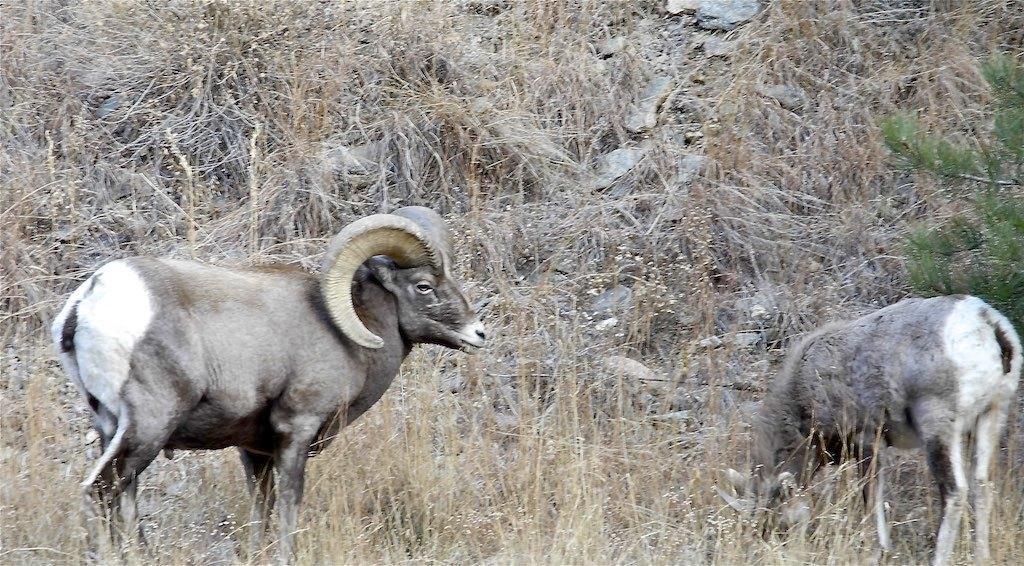Can you describe this image briefly? There are two animals standing in the grass. On the right side we can see branch of a tree. On the ground there is dried grass. 